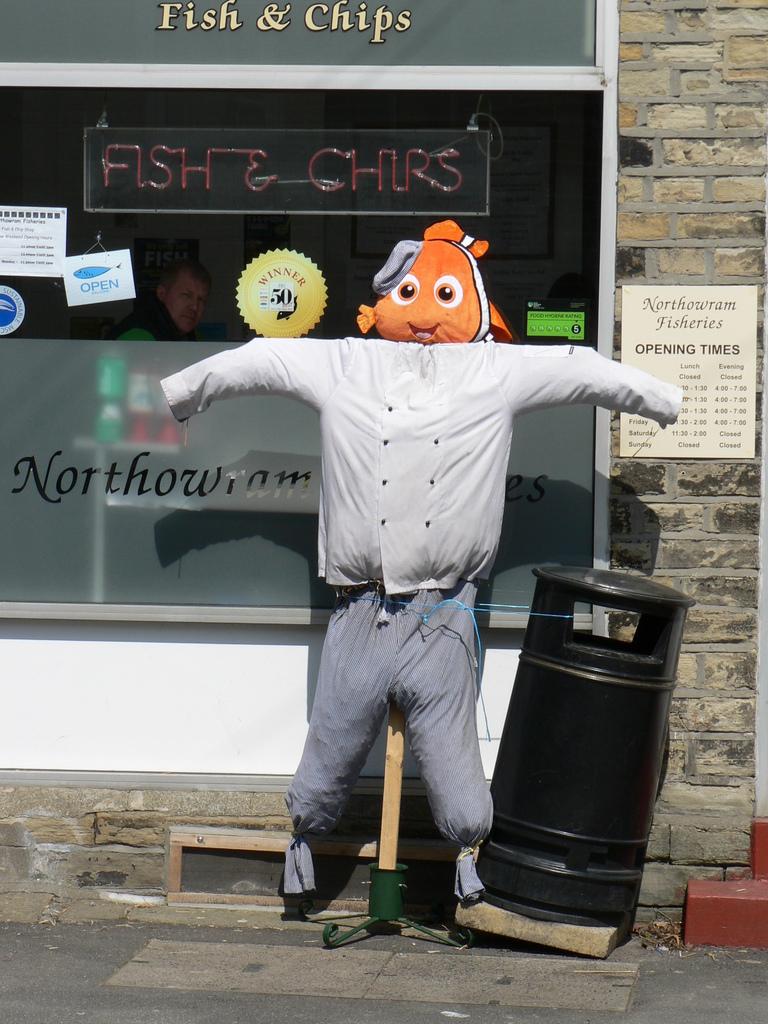What food is sold here?
Your answer should be very brief. Fish & chips. 